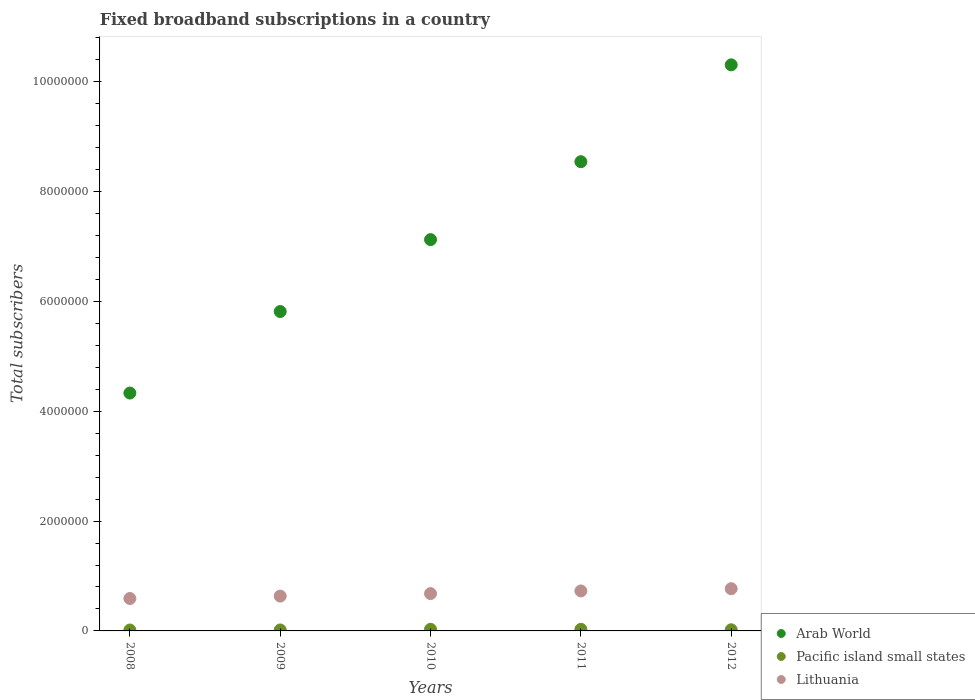Is the number of dotlines equal to the number of legend labels?
Ensure brevity in your answer.  Yes. What is the number of broadband subscriptions in Pacific island small states in 2011?
Make the answer very short. 2.92e+04. Across all years, what is the maximum number of broadband subscriptions in Lithuania?
Keep it short and to the point. 7.69e+05. Across all years, what is the minimum number of broadband subscriptions in Pacific island small states?
Your response must be concise. 1.67e+04. What is the total number of broadband subscriptions in Arab World in the graph?
Your answer should be very brief. 3.61e+07. What is the difference between the number of broadband subscriptions in Lithuania in 2008 and that in 2011?
Provide a succinct answer. -1.38e+05. What is the difference between the number of broadband subscriptions in Arab World in 2009 and the number of broadband subscriptions in Pacific island small states in 2008?
Make the answer very short. 5.80e+06. What is the average number of broadband subscriptions in Arab World per year?
Provide a short and direct response. 7.22e+06. In the year 2010, what is the difference between the number of broadband subscriptions in Lithuania and number of broadband subscriptions in Arab World?
Offer a very short reply. -6.44e+06. In how many years, is the number of broadband subscriptions in Arab World greater than 8800000?
Your answer should be compact. 1. What is the ratio of the number of broadband subscriptions in Arab World in 2009 to that in 2012?
Your response must be concise. 0.56. Is the number of broadband subscriptions in Pacific island small states in 2008 less than that in 2009?
Your answer should be very brief. Yes. Is the difference between the number of broadband subscriptions in Lithuania in 2008 and 2009 greater than the difference between the number of broadband subscriptions in Arab World in 2008 and 2009?
Offer a terse response. Yes. What is the difference between the highest and the second highest number of broadband subscriptions in Arab World?
Your answer should be compact. 1.76e+06. What is the difference between the highest and the lowest number of broadband subscriptions in Arab World?
Your answer should be compact. 5.98e+06. In how many years, is the number of broadband subscriptions in Lithuania greater than the average number of broadband subscriptions in Lithuania taken over all years?
Provide a short and direct response. 2. Is the sum of the number of broadband subscriptions in Arab World in 2008 and 2011 greater than the maximum number of broadband subscriptions in Pacific island small states across all years?
Keep it short and to the point. Yes. Is it the case that in every year, the sum of the number of broadband subscriptions in Arab World and number of broadband subscriptions in Lithuania  is greater than the number of broadband subscriptions in Pacific island small states?
Your answer should be compact. Yes. Does the number of broadband subscriptions in Lithuania monotonically increase over the years?
Offer a very short reply. Yes. Is the number of broadband subscriptions in Lithuania strictly greater than the number of broadband subscriptions in Arab World over the years?
Provide a succinct answer. No. Is the number of broadband subscriptions in Arab World strictly less than the number of broadband subscriptions in Pacific island small states over the years?
Ensure brevity in your answer.  No. How many dotlines are there?
Keep it short and to the point. 3. How many years are there in the graph?
Your answer should be very brief. 5. What is the difference between two consecutive major ticks on the Y-axis?
Offer a very short reply. 2.00e+06. Does the graph contain any zero values?
Your response must be concise. No. How are the legend labels stacked?
Your answer should be compact. Vertical. What is the title of the graph?
Offer a very short reply. Fixed broadband subscriptions in a country. What is the label or title of the X-axis?
Make the answer very short. Years. What is the label or title of the Y-axis?
Keep it short and to the point. Total subscribers. What is the Total subscribers of Arab World in 2008?
Provide a succinct answer. 4.33e+06. What is the Total subscribers of Pacific island small states in 2008?
Your response must be concise. 1.67e+04. What is the Total subscribers of Lithuania in 2008?
Your answer should be compact. 5.90e+05. What is the Total subscribers of Arab World in 2009?
Offer a very short reply. 5.81e+06. What is the Total subscribers in Pacific island small states in 2009?
Your response must be concise. 1.75e+04. What is the Total subscribers in Lithuania in 2009?
Provide a short and direct response. 6.34e+05. What is the Total subscribers of Arab World in 2010?
Ensure brevity in your answer.  7.12e+06. What is the Total subscribers of Pacific island small states in 2010?
Keep it short and to the point. 2.99e+04. What is the Total subscribers in Lithuania in 2010?
Your response must be concise. 6.79e+05. What is the Total subscribers in Arab World in 2011?
Provide a succinct answer. 8.54e+06. What is the Total subscribers in Pacific island small states in 2011?
Offer a very short reply. 2.92e+04. What is the Total subscribers in Lithuania in 2011?
Provide a succinct answer. 7.28e+05. What is the Total subscribers in Arab World in 2012?
Your answer should be very brief. 1.03e+07. What is the Total subscribers in Pacific island small states in 2012?
Keep it short and to the point. 2.10e+04. What is the Total subscribers in Lithuania in 2012?
Keep it short and to the point. 7.69e+05. Across all years, what is the maximum Total subscribers of Arab World?
Ensure brevity in your answer.  1.03e+07. Across all years, what is the maximum Total subscribers in Pacific island small states?
Keep it short and to the point. 2.99e+04. Across all years, what is the maximum Total subscribers of Lithuania?
Provide a short and direct response. 7.69e+05. Across all years, what is the minimum Total subscribers in Arab World?
Your response must be concise. 4.33e+06. Across all years, what is the minimum Total subscribers of Pacific island small states?
Keep it short and to the point. 1.67e+04. Across all years, what is the minimum Total subscribers in Lithuania?
Give a very brief answer. 5.90e+05. What is the total Total subscribers of Arab World in the graph?
Provide a succinct answer. 3.61e+07. What is the total Total subscribers of Pacific island small states in the graph?
Keep it short and to the point. 1.14e+05. What is the total Total subscribers in Lithuania in the graph?
Make the answer very short. 3.40e+06. What is the difference between the Total subscribers in Arab World in 2008 and that in 2009?
Provide a succinct answer. -1.48e+06. What is the difference between the Total subscribers of Pacific island small states in 2008 and that in 2009?
Ensure brevity in your answer.  -839. What is the difference between the Total subscribers of Lithuania in 2008 and that in 2009?
Provide a short and direct response. -4.37e+04. What is the difference between the Total subscribers in Arab World in 2008 and that in 2010?
Ensure brevity in your answer.  -2.79e+06. What is the difference between the Total subscribers in Pacific island small states in 2008 and that in 2010?
Offer a very short reply. -1.32e+04. What is the difference between the Total subscribers in Lithuania in 2008 and that in 2010?
Your answer should be compact. -8.92e+04. What is the difference between the Total subscribers of Arab World in 2008 and that in 2011?
Your answer should be very brief. -4.21e+06. What is the difference between the Total subscribers of Pacific island small states in 2008 and that in 2011?
Offer a terse response. -1.25e+04. What is the difference between the Total subscribers of Lithuania in 2008 and that in 2011?
Your response must be concise. -1.38e+05. What is the difference between the Total subscribers in Arab World in 2008 and that in 2012?
Provide a succinct answer. -5.98e+06. What is the difference between the Total subscribers in Pacific island small states in 2008 and that in 2012?
Ensure brevity in your answer.  -4292. What is the difference between the Total subscribers in Lithuania in 2008 and that in 2012?
Give a very brief answer. -1.79e+05. What is the difference between the Total subscribers of Arab World in 2009 and that in 2010?
Offer a terse response. -1.31e+06. What is the difference between the Total subscribers of Pacific island small states in 2009 and that in 2010?
Offer a terse response. -1.24e+04. What is the difference between the Total subscribers of Lithuania in 2009 and that in 2010?
Give a very brief answer. -4.55e+04. What is the difference between the Total subscribers of Arab World in 2009 and that in 2011?
Offer a very short reply. -2.73e+06. What is the difference between the Total subscribers in Pacific island small states in 2009 and that in 2011?
Give a very brief answer. -1.17e+04. What is the difference between the Total subscribers in Lithuania in 2009 and that in 2011?
Keep it short and to the point. -9.39e+04. What is the difference between the Total subscribers in Arab World in 2009 and that in 2012?
Make the answer very short. -4.49e+06. What is the difference between the Total subscribers in Pacific island small states in 2009 and that in 2012?
Make the answer very short. -3453. What is the difference between the Total subscribers of Lithuania in 2009 and that in 2012?
Keep it short and to the point. -1.35e+05. What is the difference between the Total subscribers of Arab World in 2010 and that in 2011?
Keep it short and to the point. -1.42e+06. What is the difference between the Total subscribers of Pacific island small states in 2010 and that in 2011?
Offer a terse response. 690. What is the difference between the Total subscribers in Lithuania in 2010 and that in 2011?
Keep it short and to the point. -4.84e+04. What is the difference between the Total subscribers of Arab World in 2010 and that in 2012?
Keep it short and to the point. -3.18e+06. What is the difference between the Total subscribers of Pacific island small states in 2010 and that in 2012?
Ensure brevity in your answer.  8905. What is the difference between the Total subscribers of Lithuania in 2010 and that in 2012?
Your answer should be very brief. -8.95e+04. What is the difference between the Total subscribers of Arab World in 2011 and that in 2012?
Offer a terse response. -1.76e+06. What is the difference between the Total subscribers of Pacific island small states in 2011 and that in 2012?
Provide a succinct answer. 8215. What is the difference between the Total subscribers in Lithuania in 2011 and that in 2012?
Offer a very short reply. -4.12e+04. What is the difference between the Total subscribers of Arab World in 2008 and the Total subscribers of Pacific island small states in 2009?
Keep it short and to the point. 4.31e+06. What is the difference between the Total subscribers in Arab World in 2008 and the Total subscribers in Lithuania in 2009?
Provide a short and direct response. 3.70e+06. What is the difference between the Total subscribers of Pacific island small states in 2008 and the Total subscribers of Lithuania in 2009?
Ensure brevity in your answer.  -6.17e+05. What is the difference between the Total subscribers of Arab World in 2008 and the Total subscribers of Pacific island small states in 2010?
Offer a very short reply. 4.30e+06. What is the difference between the Total subscribers of Arab World in 2008 and the Total subscribers of Lithuania in 2010?
Offer a very short reply. 3.65e+06. What is the difference between the Total subscribers of Pacific island small states in 2008 and the Total subscribers of Lithuania in 2010?
Ensure brevity in your answer.  -6.63e+05. What is the difference between the Total subscribers of Arab World in 2008 and the Total subscribers of Pacific island small states in 2011?
Make the answer very short. 4.30e+06. What is the difference between the Total subscribers in Arab World in 2008 and the Total subscribers in Lithuania in 2011?
Give a very brief answer. 3.60e+06. What is the difference between the Total subscribers in Pacific island small states in 2008 and the Total subscribers in Lithuania in 2011?
Ensure brevity in your answer.  -7.11e+05. What is the difference between the Total subscribers in Arab World in 2008 and the Total subscribers in Pacific island small states in 2012?
Provide a succinct answer. 4.31e+06. What is the difference between the Total subscribers in Arab World in 2008 and the Total subscribers in Lithuania in 2012?
Provide a short and direct response. 3.56e+06. What is the difference between the Total subscribers of Pacific island small states in 2008 and the Total subscribers of Lithuania in 2012?
Offer a terse response. -7.52e+05. What is the difference between the Total subscribers of Arab World in 2009 and the Total subscribers of Pacific island small states in 2010?
Keep it short and to the point. 5.79e+06. What is the difference between the Total subscribers of Arab World in 2009 and the Total subscribers of Lithuania in 2010?
Your response must be concise. 5.14e+06. What is the difference between the Total subscribers of Pacific island small states in 2009 and the Total subscribers of Lithuania in 2010?
Provide a succinct answer. -6.62e+05. What is the difference between the Total subscribers of Arab World in 2009 and the Total subscribers of Pacific island small states in 2011?
Offer a terse response. 5.79e+06. What is the difference between the Total subscribers in Arab World in 2009 and the Total subscribers in Lithuania in 2011?
Give a very brief answer. 5.09e+06. What is the difference between the Total subscribers of Pacific island small states in 2009 and the Total subscribers of Lithuania in 2011?
Give a very brief answer. -7.10e+05. What is the difference between the Total subscribers of Arab World in 2009 and the Total subscribers of Pacific island small states in 2012?
Give a very brief answer. 5.79e+06. What is the difference between the Total subscribers in Arab World in 2009 and the Total subscribers in Lithuania in 2012?
Your response must be concise. 5.05e+06. What is the difference between the Total subscribers of Pacific island small states in 2009 and the Total subscribers of Lithuania in 2012?
Your response must be concise. -7.51e+05. What is the difference between the Total subscribers of Arab World in 2010 and the Total subscribers of Pacific island small states in 2011?
Your answer should be very brief. 7.09e+06. What is the difference between the Total subscribers in Arab World in 2010 and the Total subscribers in Lithuania in 2011?
Your response must be concise. 6.40e+06. What is the difference between the Total subscribers of Pacific island small states in 2010 and the Total subscribers of Lithuania in 2011?
Provide a short and direct response. -6.98e+05. What is the difference between the Total subscribers in Arab World in 2010 and the Total subscribers in Pacific island small states in 2012?
Provide a succinct answer. 7.10e+06. What is the difference between the Total subscribers of Arab World in 2010 and the Total subscribers of Lithuania in 2012?
Your answer should be very brief. 6.35e+06. What is the difference between the Total subscribers in Pacific island small states in 2010 and the Total subscribers in Lithuania in 2012?
Keep it short and to the point. -7.39e+05. What is the difference between the Total subscribers in Arab World in 2011 and the Total subscribers in Pacific island small states in 2012?
Offer a very short reply. 8.52e+06. What is the difference between the Total subscribers of Arab World in 2011 and the Total subscribers of Lithuania in 2012?
Provide a short and direct response. 7.77e+06. What is the difference between the Total subscribers in Pacific island small states in 2011 and the Total subscribers in Lithuania in 2012?
Your answer should be compact. -7.40e+05. What is the average Total subscribers of Arab World per year?
Offer a very short reply. 7.22e+06. What is the average Total subscribers of Pacific island small states per year?
Your response must be concise. 2.29e+04. What is the average Total subscribers in Lithuania per year?
Provide a succinct answer. 6.80e+05. In the year 2008, what is the difference between the Total subscribers in Arab World and Total subscribers in Pacific island small states?
Offer a terse response. 4.31e+06. In the year 2008, what is the difference between the Total subscribers of Arab World and Total subscribers of Lithuania?
Your answer should be compact. 3.74e+06. In the year 2008, what is the difference between the Total subscribers of Pacific island small states and Total subscribers of Lithuania?
Ensure brevity in your answer.  -5.73e+05. In the year 2009, what is the difference between the Total subscribers in Arab World and Total subscribers in Pacific island small states?
Your answer should be very brief. 5.80e+06. In the year 2009, what is the difference between the Total subscribers in Arab World and Total subscribers in Lithuania?
Your response must be concise. 5.18e+06. In the year 2009, what is the difference between the Total subscribers of Pacific island small states and Total subscribers of Lithuania?
Offer a very short reply. -6.16e+05. In the year 2010, what is the difference between the Total subscribers of Arab World and Total subscribers of Pacific island small states?
Your answer should be very brief. 7.09e+06. In the year 2010, what is the difference between the Total subscribers in Arab World and Total subscribers in Lithuania?
Your response must be concise. 6.44e+06. In the year 2010, what is the difference between the Total subscribers of Pacific island small states and Total subscribers of Lithuania?
Your answer should be very brief. -6.49e+05. In the year 2011, what is the difference between the Total subscribers of Arab World and Total subscribers of Pacific island small states?
Keep it short and to the point. 8.51e+06. In the year 2011, what is the difference between the Total subscribers of Arab World and Total subscribers of Lithuania?
Your answer should be compact. 7.82e+06. In the year 2011, what is the difference between the Total subscribers of Pacific island small states and Total subscribers of Lithuania?
Keep it short and to the point. -6.98e+05. In the year 2012, what is the difference between the Total subscribers of Arab World and Total subscribers of Pacific island small states?
Offer a very short reply. 1.03e+07. In the year 2012, what is the difference between the Total subscribers in Arab World and Total subscribers in Lithuania?
Give a very brief answer. 9.54e+06. In the year 2012, what is the difference between the Total subscribers in Pacific island small states and Total subscribers in Lithuania?
Provide a short and direct response. -7.48e+05. What is the ratio of the Total subscribers of Arab World in 2008 to that in 2009?
Your answer should be very brief. 0.74. What is the ratio of the Total subscribers in Pacific island small states in 2008 to that in 2009?
Make the answer very short. 0.95. What is the ratio of the Total subscribers of Lithuania in 2008 to that in 2009?
Keep it short and to the point. 0.93. What is the ratio of the Total subscribers in Arab World in 2008 to that in 2010?
Your response must be concise. 0.61. What is the ratio of the Total subscribers of Pacific island small states in 2008 to that in 2010?
Offer a very short reply. 0.56. What is the ratio of the Total subscribers in Lithuania in 2008 to that in 2010?
Ensure brevity in your answer.  0.87. What is the ratio of the Total subscribers in Arab World in 2008 to that in 2011?
Provide a short and direct response. 0.51. What is the ratio of the Total subscribers of Pacific island small states in 2008 to that in 2011?
Offer a terse response. 0.57. What is the ratio of the Total subscribers in Lithuania in 2008 to that in 2011?
Keep it short and to the point. 0.81. What is the ratio of the Total subscribers in Arab World in 2008 to that in 2012?
Your answer should be very brief. 0.42. What is the ratio of the Total subscribers in Pacific island small states in 2008 to that in 2012?
Ensure brevity in your answer.  0.8. What is the ratio of the Total subscribers of Lithuania in 2008 to that in 2012?
Offer a very short reply. 0.77. What is the ratio of the Total subscribers in Arab World in 2009 to that in 2010?
Offer a terse response. 0.82. What is the ratio of the Total subscribers of Pacific island small states in 2009 to that in 2010?
Offer a very short reply. 0.59. What is the ratio of the Total subscribers of Lithuania in 2009 to that in 2010?
Give a very brief answer. 0.93. What is the ratio of the Total subscribers of Arab World in 2009 to that in 2011?
Provide a succinct answer. 0.68. What is the ratio of the Total subscribers of Pacific island small states in 2009 to that in 2011?
Give a very brief answer. 0.6. What is the ratio of the Total subscribers of Lithuania in 2009 to that in 2011?
Ensure brevity in your answer.  0.87. What is the ratio of the Total subscribers in Arab World in 2009 to that in 2012?
Provide a succinct answer. 0.56. What is the ratio of the Total subscribers in Pacific island small states in 2009 to that in 2012?
Offer a very short reply. 0.84. What is the ratio of the Total subscribers in Lithuania in 2009 to that in 2012?
Offer a terse response. 0.82. What is the ratio of the Total subscribers in Arab World in 2010 to that in 2011?
Offer a terse response. 0.83. What is the ratio of the Total subscribers of Pacific island small states in 2010 to that in 2011?
Give a very brief answer. 1.02. What is the ratio of the Total subscribers in Lithuania in 2010 to that in 2011?
Offer a terse response. 0.93. What is the ratio of the Total subscribers in Arab World in 2010 to that in 2012?
Give a very brief answer. 0.69. What is the ratio of the Total subscribers of Pacific island small states in 2010 to that in 2012?
Your answer should be compact. 1.42. What is the ratio of the Total subscribers in Lithuania in 2010 to that in 2012?
Keep it short and to the point. 0.88. What is the ratio of the Total subscribers of Arab World in 2011 to that in 2012?
Ensure brevity in your answer.  0.83. What is the ratio of the Total subscribers of Pacific island small states in 2011 to that in 2012?
Your response must be concise. 1.39. What is the ratio of the Total subscribers of Lithuania in 2011 to that in 2012?
Your answer should be very brief. 0.95. What is the difference between the highest and the second highest Total subscribers of Arab World?
Provide a succinct answer. 1.76e+06. What is the difference between the highest and the second highest Total subscribers of Pacific island small states?
Provide a short and direct response. 690. What is the difference between the highest and the second highest Total subscribers of Lithuania?
Make the answer very short. 4.12e+04. What is the difference between the highest and the lowest Total subscribers in Arab World?
Your answer should be very brief. 5.98e+06. What is the difference between the highest and the lowest Total subscribers of Pacific island small states?
Give a very brief answer. 1.32e+04. What is the difference between the highest and the lowest Total subscribers of Lithuania?
Your answer should be very brief. 1.79e+05. 